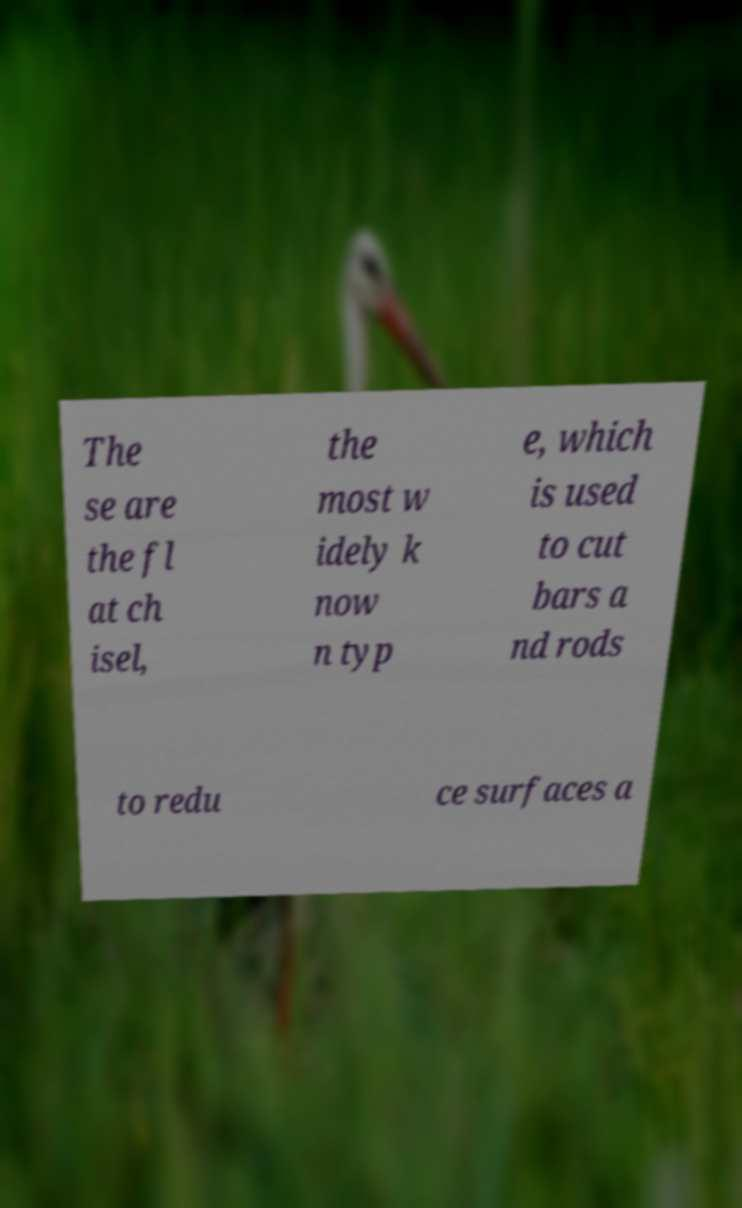For documentation purposes, I need the text within this image transcribed. Could you provide that? The se are the fl at ch isel, the most w idely k now n typ e, which is used to cut bars a nd rods to redu ce surfaces a 